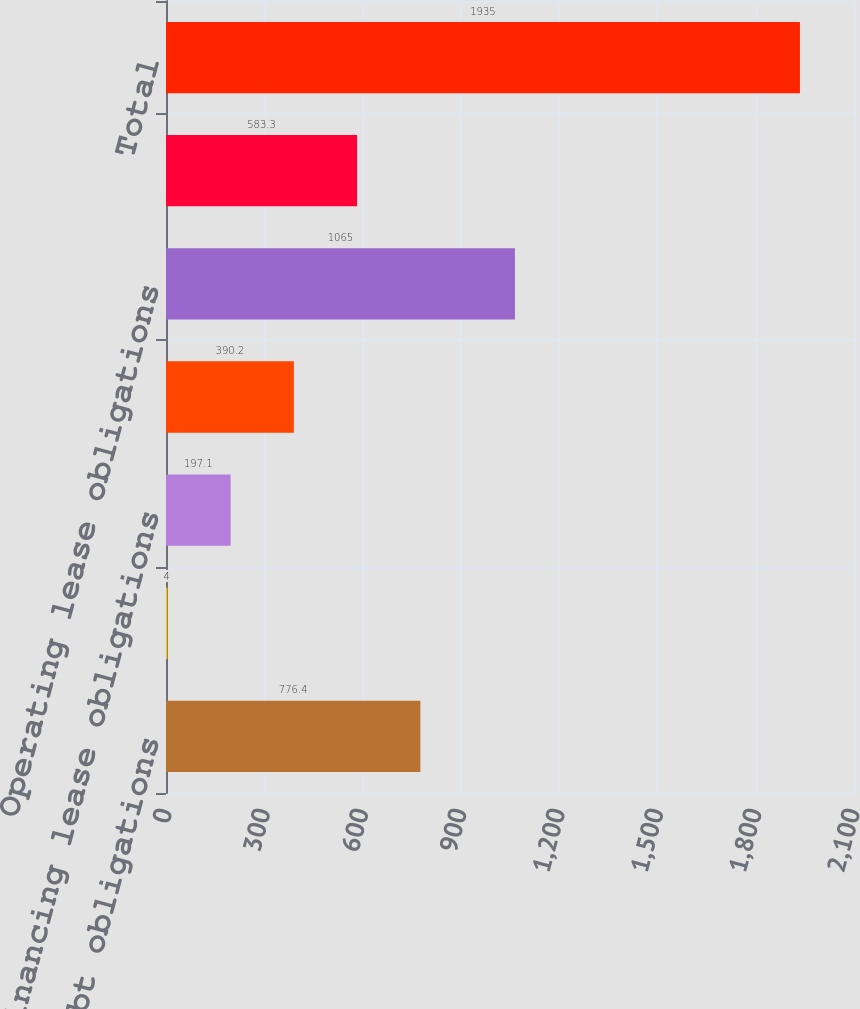Convert chart. <chart><loc_0><loc_0><loc_500><loc_500><bar_chart><fcel>Long-term debt obligations<fcel>Capital lease obligations<fcel>Financing lease obligations<fcel>Interest payments<fcel>Operating lease obligations<fcel>Purchase obligations (1)<fcel>Total<nl><fcel>776.4<fcel>4<fcel>197.1<fcel>390.2<fcel>1065<fcel>583.3<fcel>1935<nl></chart> 